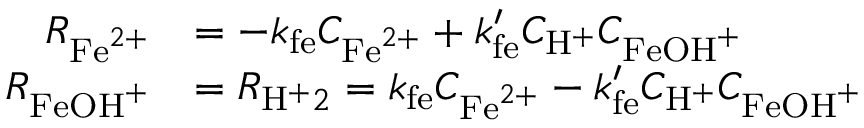Convert formula to latex. <formula><loc_0><loc_0><loc_500><loc_500>\begin{array} { r l } { R _ { F e ^ { 2 + } } } & { = - k _ { f e } C _ { F e ^ { 2 + } } + k _ { f e } ^ { \prime } C _ { H ^ { + } } C _ { F e O H ^ { + } } } \\ { R _ { F e O H ^ { + } } } & { = R _ { H ^ { + } 2 } = k _ { f e } C _ { F e ^ { 2 + } } - k _ { f e } ^ { \prime } C _ { H ^ { + } } C _ { F e O H ^ { + } } } \end{array}</formula> 